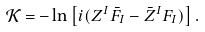<formula> <loc_0><loc_0><loc_500><loc_500>\mathcal { K } = - \ln \left [ i ( Z ^ { I } \bar { F } _ { I } - \bar { Z } ^ { I } F _ { I } ) \right ] .</formula> 